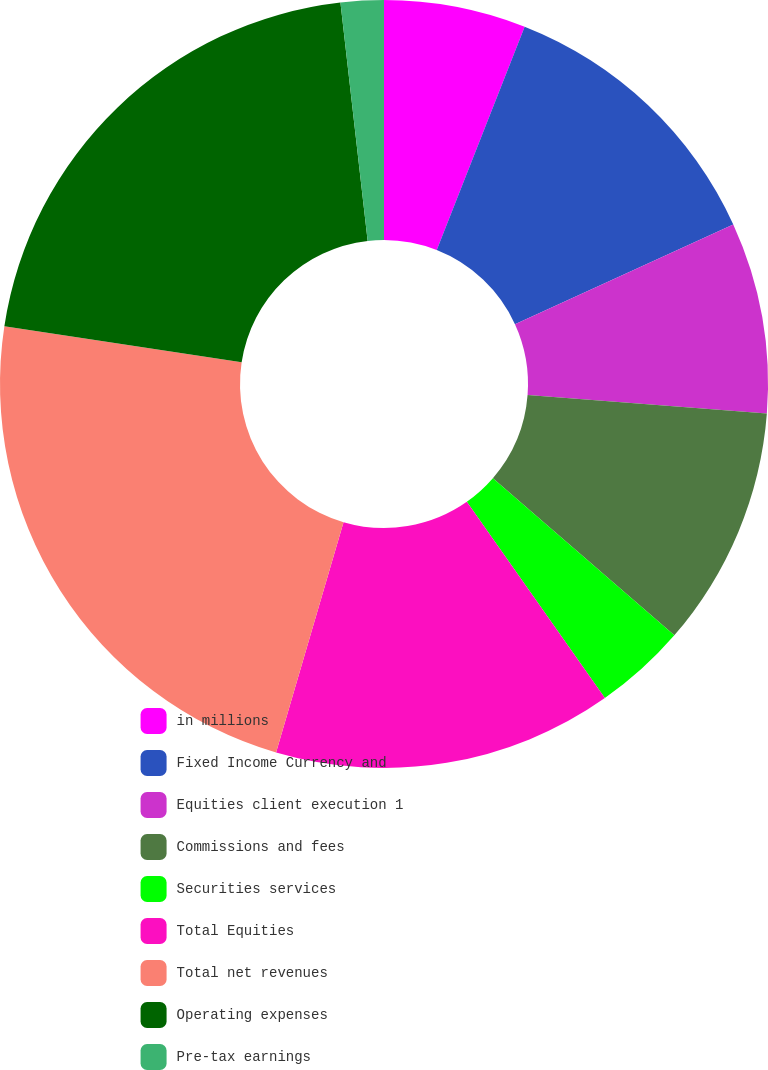Convert chart. <chart><loc_0><loc_0><loc_500><loc_500><pie_chart><fcel>in millions<fcel>Fixed Income Currency and<fcel>Equities client execution 1<fcel>Commissions and fees<fcel>Securities services<fcel>Total Equities<fcel>Total net revenues<fcel>Operating expenses<fcel>Pre-tax earnings<nl><fcel>5.97%<fcel>12.21%<fcel>8.05%<fcel>10.13%<fcel>3.89%<fcel>14.29%<fcel>22.87%<fcel>20.79%<fcel>1.81%<nl></chart> 